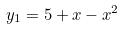<formula> <loc_0><loc_0><loc_500><loc_500>y _ { 1 } = 5 + x - x ^ { 2 }</formula> 